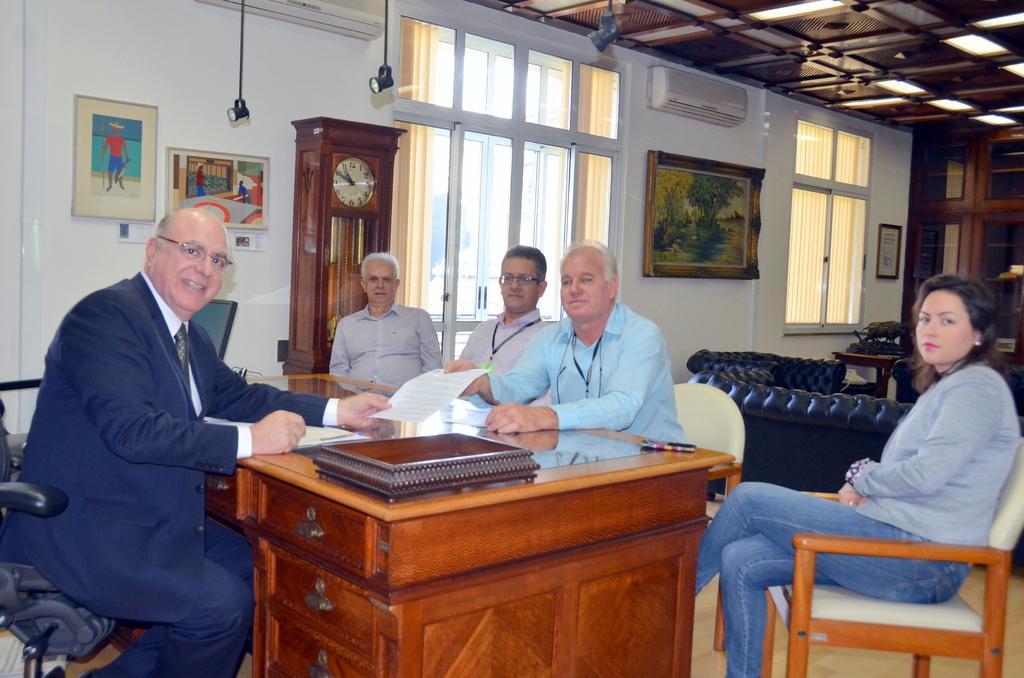How would you summarize this image in a sentence or two? In this an image there a table on which some books are kept and pens are kept and there are some people sitting on the chair and in the background there is a wall on which some pictures are placed and there is AC which is on the wall. 